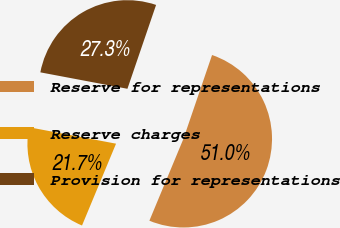<chart> <loc_0><loc_0><loc_500><loc_500><pie_chart><fcel>Reserve for representations<fcel>Reserve charges<fcel>Provision for representations<nl><fcel>51.03%<fcel>21.7%<fcel>27.27%<nl></chart> 